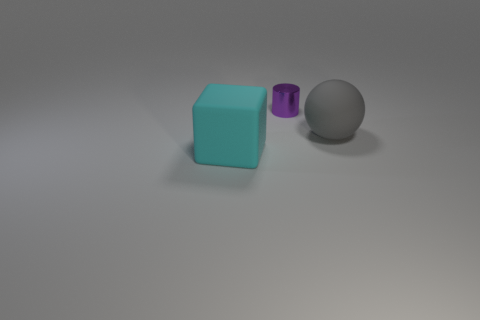There is a large thing that is to the right of the rubber object that is left of the object that is behind the matte ball; what shape is it?
Ensure brevity in your answer.  Sphere. What is the color of the object that is both in front of the tiny shiny object and on the right side of the large cyan cube?
Provide a short and direct response. Gray. The thing behind the big gray rubber thing has what shape?
Provide a succinct answer. Cylinder. What is the shape of the gray object that is the same material as the cyan thing?
Provide a short and direct response. Sphere. How many shiny objects are either purple cylinders or big blocks?
Offer a very short reply. 1. There is a large object that is behind the large object in front of the large gray ball; what number of balls are to the left of it?
Keep it short and to the point. 0. There is a object that is left of the small purple metal object; is it the same size as the object behind the gray matte object?
Ensure brevity in your answer.  No. What number of big objects are either rubber things or cubes?
Keep it short and to the point. 2. What material is the gray object?
Offer a very short reply. Rubber. The thing that is behind the cube and to the left of the gray rubber sphere is made of what material?
Provide a short and direct response. Metal. 